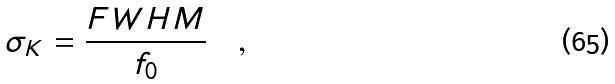<formula> <loc_0><loc_0><loc_500><loc_500>\sigma _ { K } = \frac { F W H M } { f _ { 0 } } \quad ,</formula> 